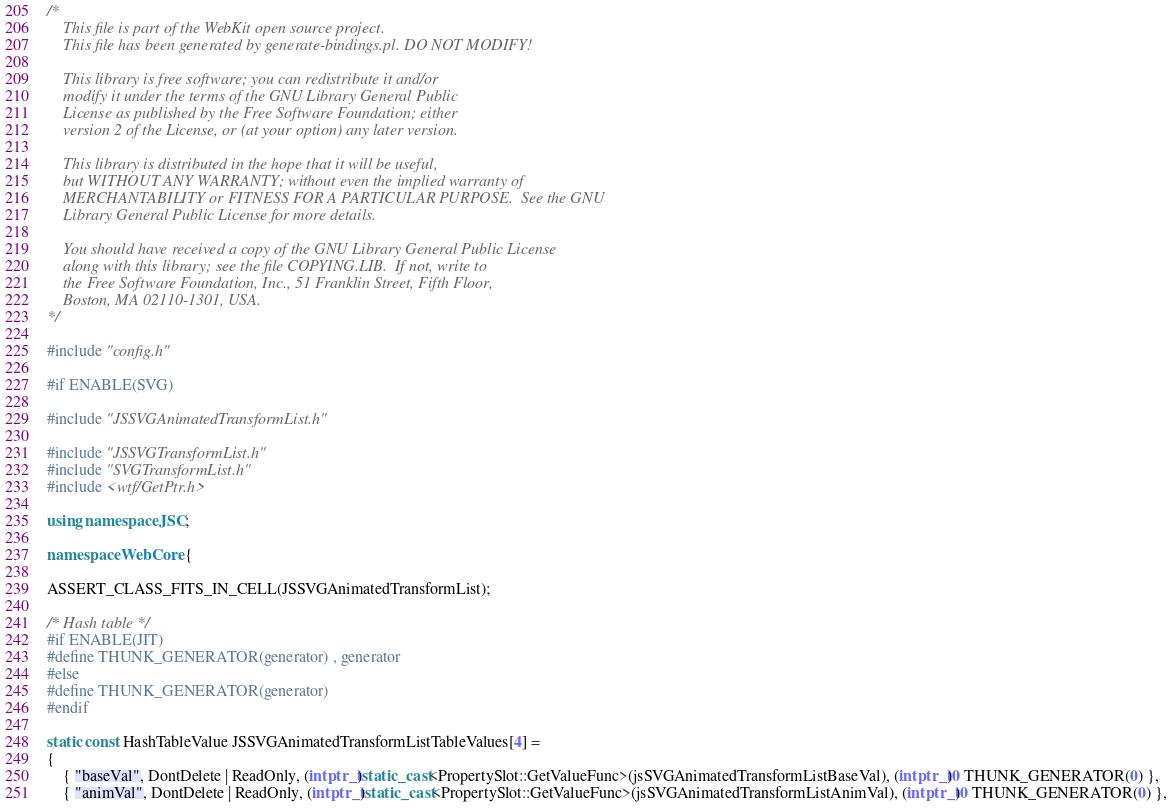<code> <loc_0><loc_0><loc_500><loc_500><_C++_>/*
    This file is part of the WebKit open source project.
    This file has been generated by generate-bindings.pl. DO NOT MODIFY!

    This library is free software; you can redistribute it and/or
    modify it under the terms of the GNU Library General Public
    License as published by the Free Software Foundation; either
    version 2 of the License, or (at your option) any later version.

    This library is distributed in the hope that it will be useful,
    but WITHOUT ANY WARRANTY; without even the implied warranty of
    MERCHANTABILITY or FITNESS FOR A PARTICULAR PURPOSE.  See the GNU
    Library General Public License for more details.

    You should have received a copy of the GNU Library General Public License
    along with this library; see the file COPYING.LIB.  If not, write to
    the Free Software Foundation, Inc., 51 Franklin Street, Fifth Floor,
    Boston, MA 02110-1301, USA.
*/

#include "config.h"

#if ENABLE(SVG)

#include "JSSVGAnimatedTransformList.h"

#include "JSSVGTransformList.h"
#include "SVGTransformList.h"
#include <wtf/GetPtr.h>

using namespace JSC;

namespace WebCore {

ASSERT_CLASS_FITS_IN_CELL(JSSVGAnimatedTransformList);

/* Hash table */
#if ENABLE(JIT)
#define THUNK_GENERATOR(generator) , generator
#else
#define THUNK_GENERATOR(generator)
#endif

static const HashTableValue JSSVGAnimatedTransformListTableValues[4] =
{
    { "baseVal", DontDelete | ReadOnly, (intptr_t)static_cast<PropertySlot::GetValueFunc>(jsSVGAnimatedTransformListBaseVal), (intptr_t)0 THUNK_GENERATOR(0) },
    { "animVal", DontDelete | ReadOnly, (intptr_t)static_cast<PropertySlot::GetValueFunc>(jsSVGAnimatedTransformListAnimVal), (intptr_t)0 THUNK_GENERATOR(0) },</code> 